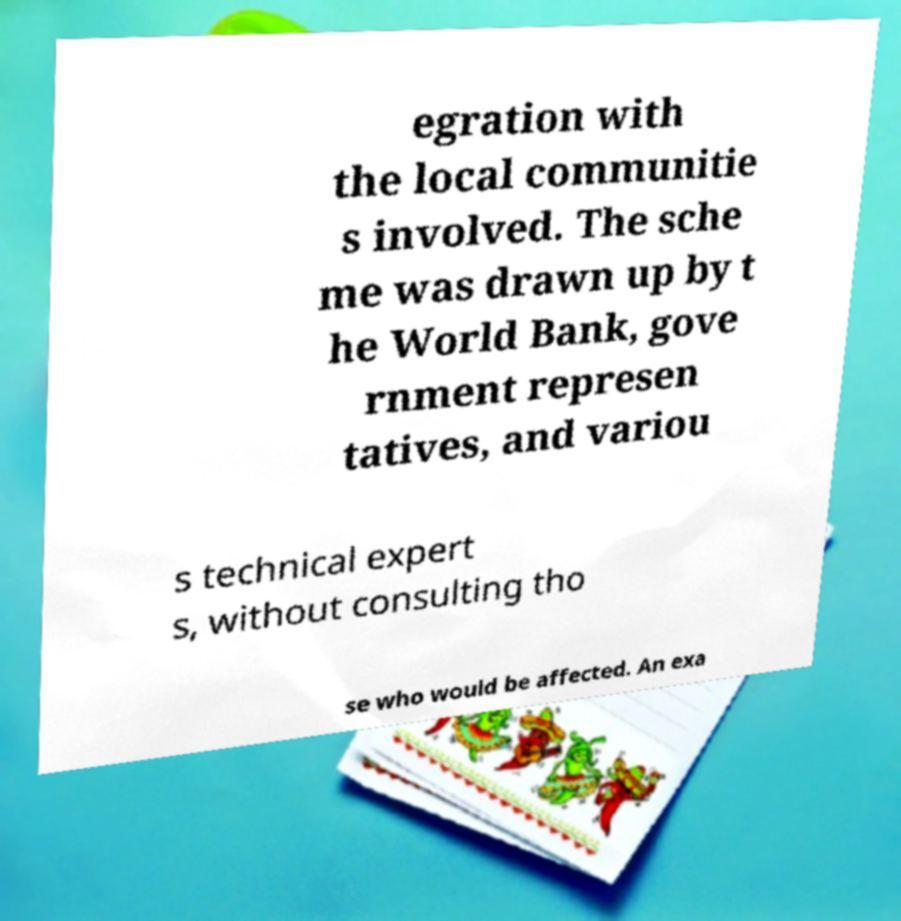There's text embedded in this image that I need extracted. Can you transcribe it verbatim? egration with the local communitie s involved. The sche me was drawn up by t he World Bank, gove rnment represen tatives, and variou s technical expert s, without consulting tho se who would be affected. An exa 